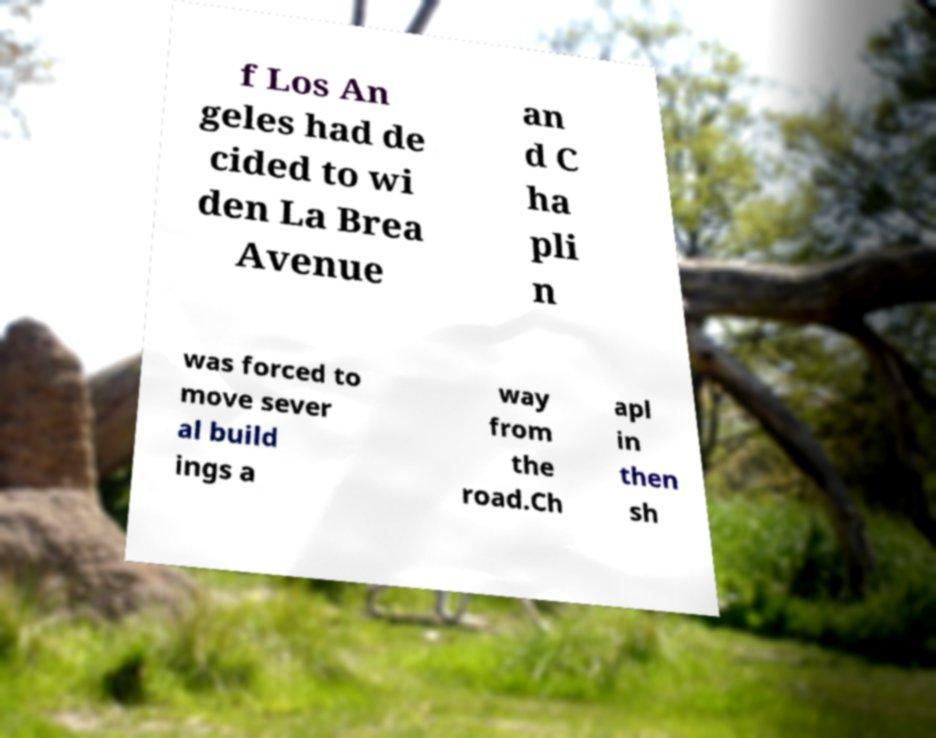Could you extract and type out the text from this image? f Los An geles had de cided to wi den La Brea Avenue an d C ha pli n was forced to move sever al build ings a way from the road.Ch apl in then sh 